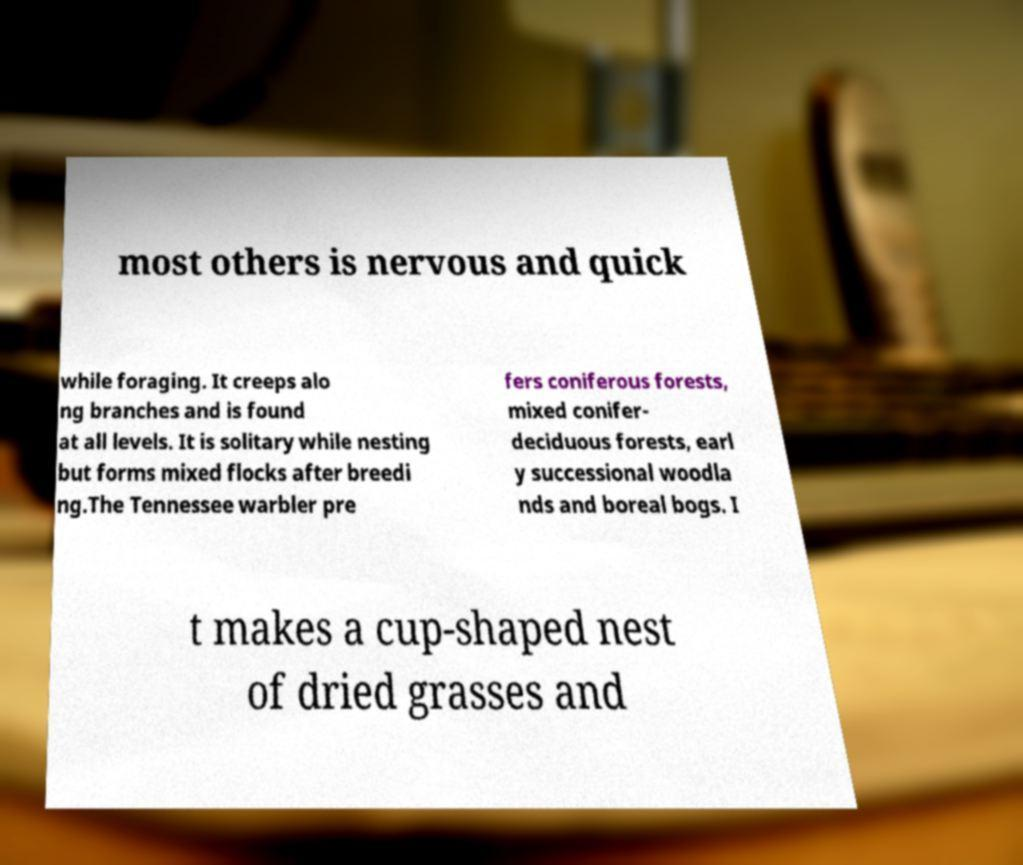Can you accurately transcribe the text from the provided image for me? most others is nervous and quick while foraging. It creeps alo ng branches and is found at all levels. It is solitary while nesting but forms mixed flocks after breedi ng.The Tennessee warbler pre fers coniferous forests, mixed conifer- deciduous forests, earl y successional woodla nds and boreal bogs. I t makes a cup-shaped nest of dried grasses and 